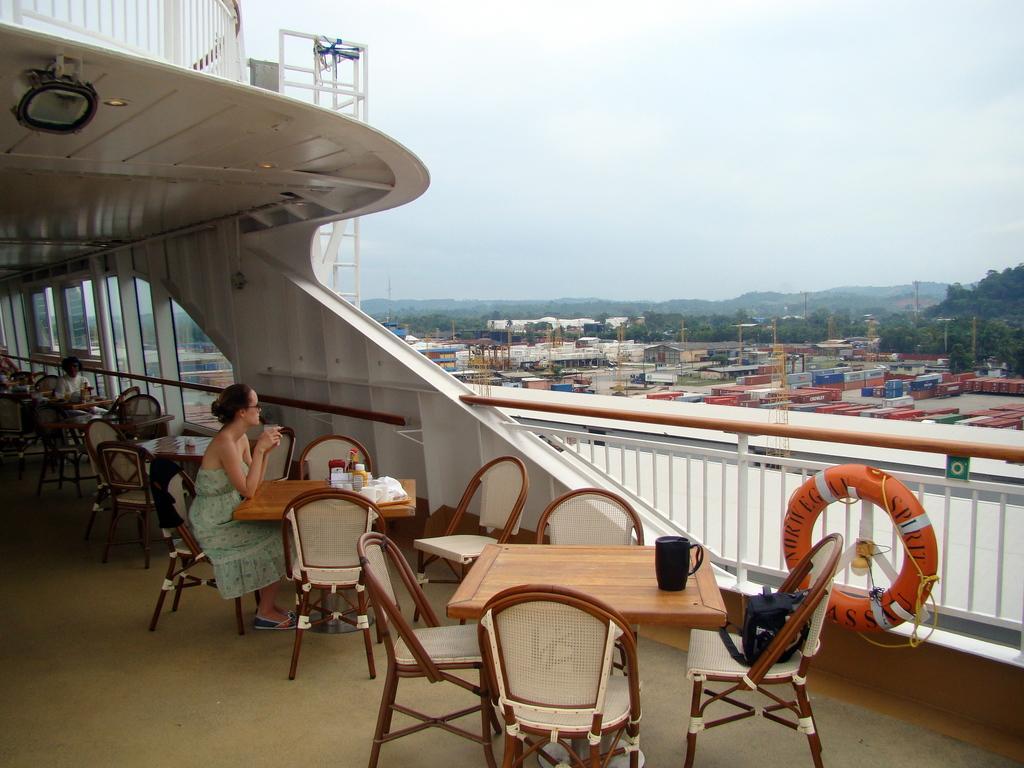How would you summarize this image in a sentence or two? A lady sitting on a chair holding glass. There are tables and chairs. On the table there is a jug. On the chair there is a bag. In the background there are many buildings, trees and sky. There is a tube on the railings of this building. 